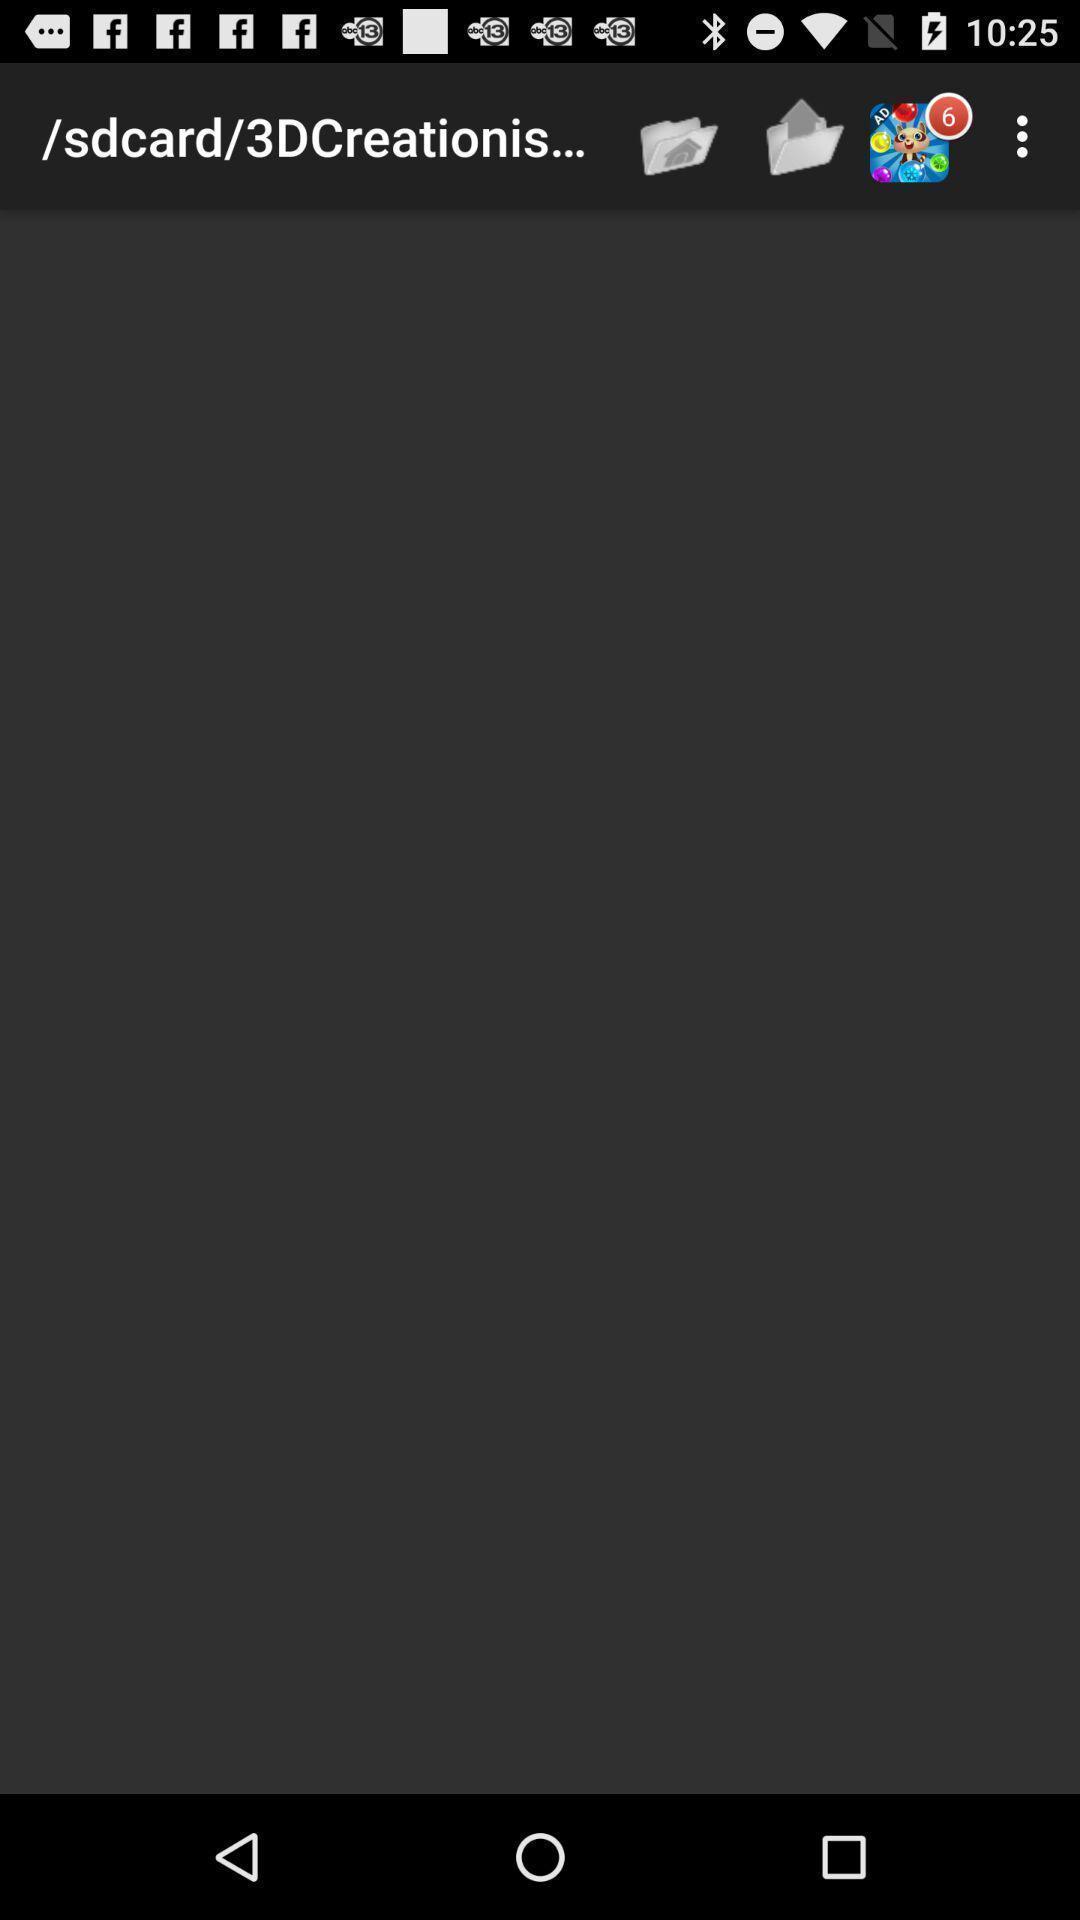Describe the content in this image. Page displaying the address of a folder with other options. 